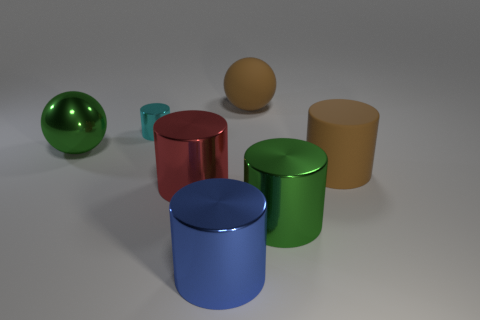Add 1 big spheres. How many objects exist? 8 Subtract all large brown matte cylinders. How many cylinders are left? 4 Subtract 2 balls. How many balls are left? 0 Subtract all blue cylinders. How many cylinders are left? 4 Subtract all cylinders. How many objects are left? 2 Subtract all red metallic things. Subtract all red cylinders. How many objects are left? 5 Add 2 large brown objects. How many large brown objects are left? 4 Add 1 large blue shiny cylinders. How many large blue shiny cylinders exist? 2 Subtract 1 green cylinders. How many objects are left? 6 Subtract all green balls. Subtract all red blocks. How many balls are left? 1 